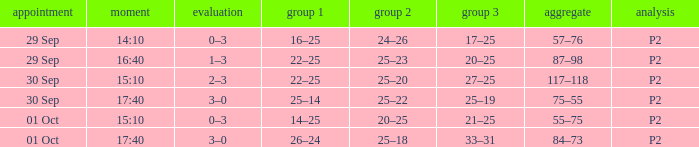Would you mind parsing the complete table? {'header': ['appointment', 'moment', 'evaluation', 'group 1', 'group 2', 'group 3', 'aggregate', 'analysis'], 'rows': [['29 Sep', '14:10', '0–3', '16–25', '24–26', '17–25', '57–76', 'P2'], ['29 Sep', '16:40', '1–3', '22–25', '25–23', '20–25', '87–98', 'P2'], ['30 Sep', '15:10', '2–3', '22–25', '25–20', '27–25', '117–118', 'P2'], ['30 Sep', '17:40', '3–0', '25–14', '25–22', '25–19', '75–55', 'P2'], ['01 Oct', '15:10', '0–3', '14–25', '20–25', '21–25', '55–75', 'P2'], ['01 Oct', '17:40', '3–0', '26–24', '25–18', '33–31', '84–73', 'P2']]} For a date of 29 Sep and a time of 16:40, what is the corresponding Set 3? 20–25. 